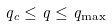<formula> <loc_0><loc_0><loc_500><loc_500>q _ { c } \leq q \leq q _ { \max }</formula> 